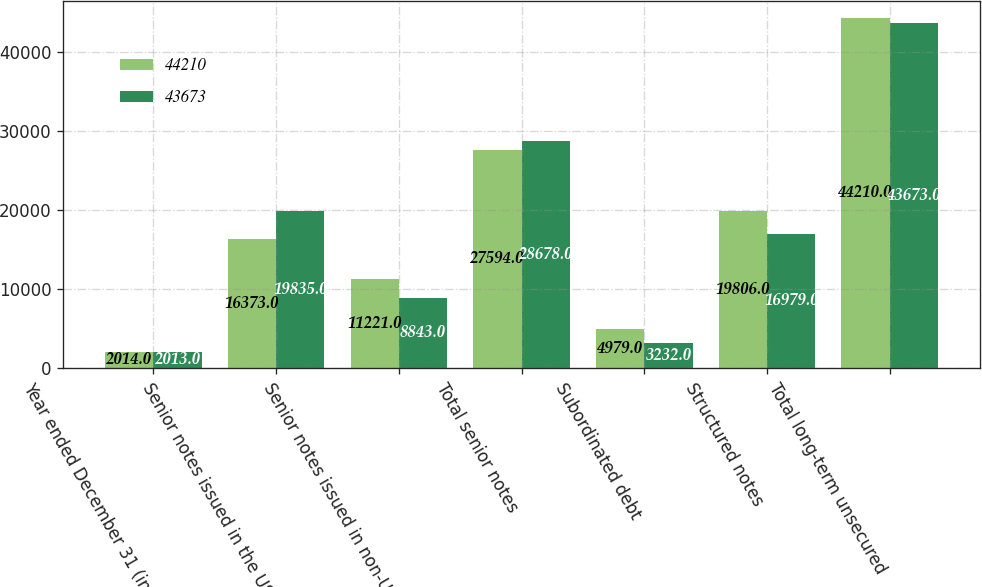Convert chart to OTSL. <chart><loc_0><loc_0><loc_500><loc_500><stacked_bar_chart><ecel><fcel>Year ended December 31 (in<fcel>Senior notes issued in the US<fcel>Senior notes issued in non-US<fcel>Total senior notes<fcel>Subordinated debt<fcel>Structured notes<fcel>Total long-term unsecured<nl><fcel>44210<fcel>2014<fcel>16373<fcel>11221<fcel>27594<fcel>4979<fcel>19806<fcel>44210<nl><fcel>43673<fcel>2013<fcel>19835<fcel>8843<fcel>28678<fcel>3232<fcel>16979<fcel>43673<nl></chart> 